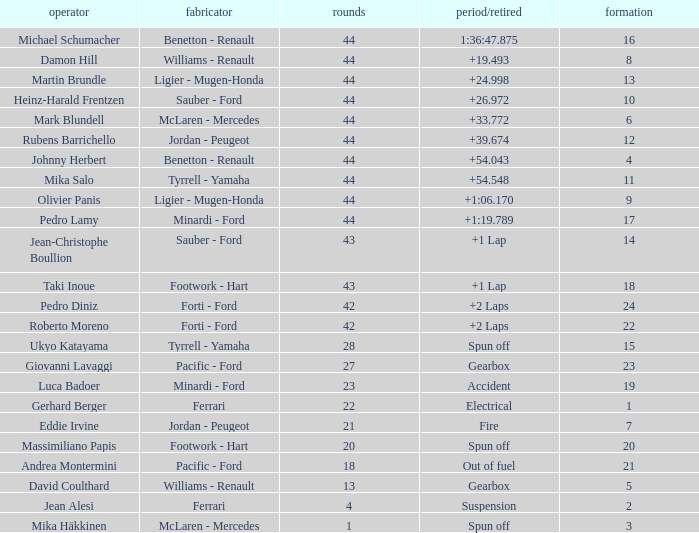What is the high lap total for cards with a grid larger than 21, and a Time/Retired of +2 laps? 42.0. 